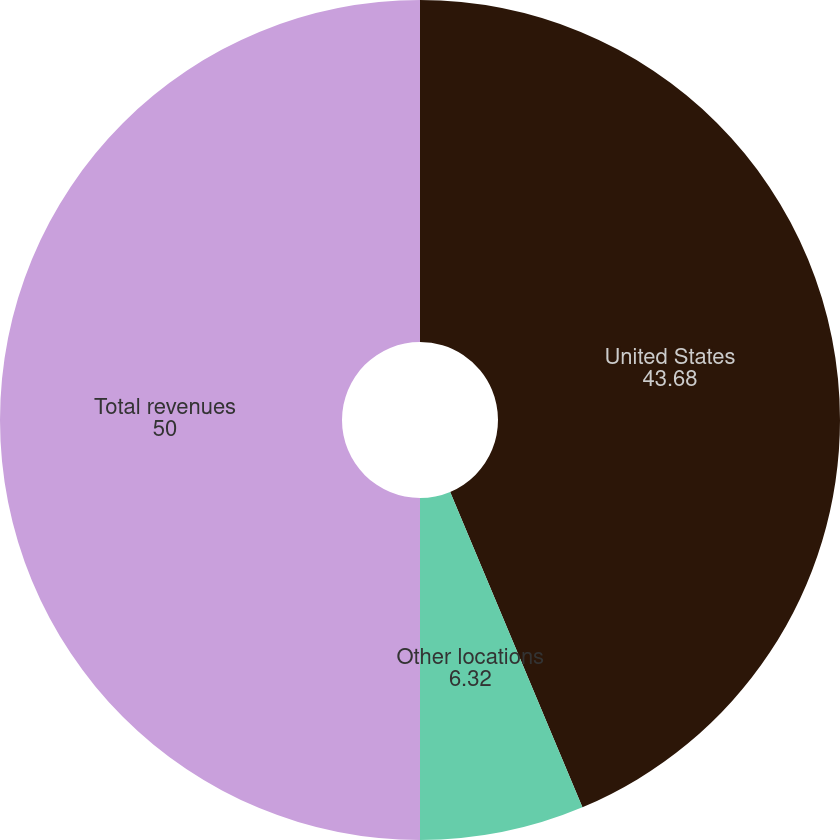Convert chart to OTSL. <chart><loc_0><loc_0><loc_500><loc_500><pie_chart><fcel>United States<fcel>Other locations<fcel>Total revenues<nl><fcel>43.68%<fcel>6.32%<fcel>50.0%<nl></chart> 